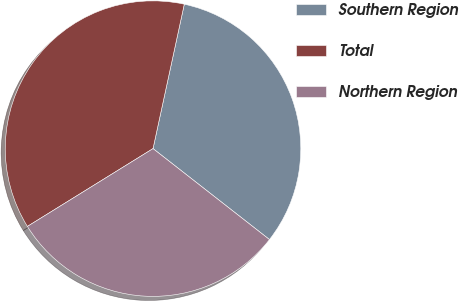<chart> <loc_0><loc_0><loc_500><loc_500><pie_chart><fcel>Southern Region<fcel>Total<fcel>Northern Region<nl><fcel>32.16%<fcel>37.22%<fcel>30.62%<nl></chart> 